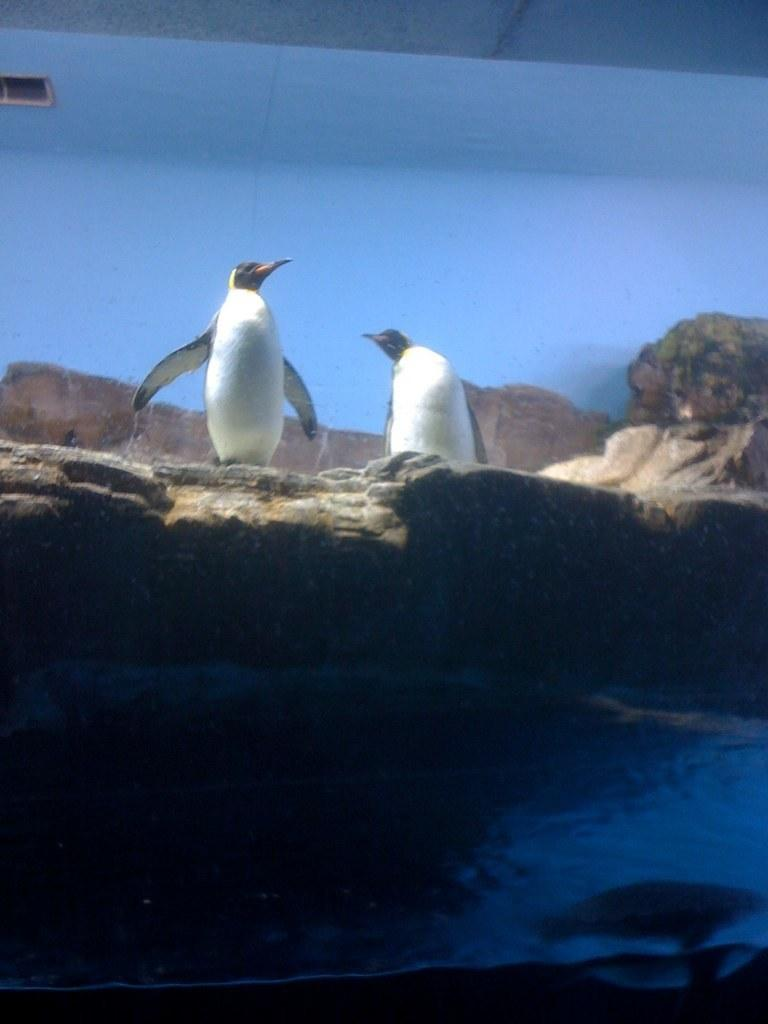What type of animals are present in the image? A: There are penguins in the image. What other elements can be seen in the image besides the penguins? There are rocks and water visible in the image. What might be the purpose of the wall in the background of the image? The wall in the background of the image could serve as a barrier or boundary. What type of operation is being performed on the penguins in the image? There is no operation being performed on the penguins in the image; they are simply present in their natural environment. 